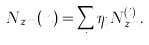Convert formula to latex. <formula><loc_0><loc_0><loc_500><loc_500>N _ { z m } ( n ) = \sum _ { i } \eta _ { i } N _ { z m } ^ { ( i ) } .</formula> 